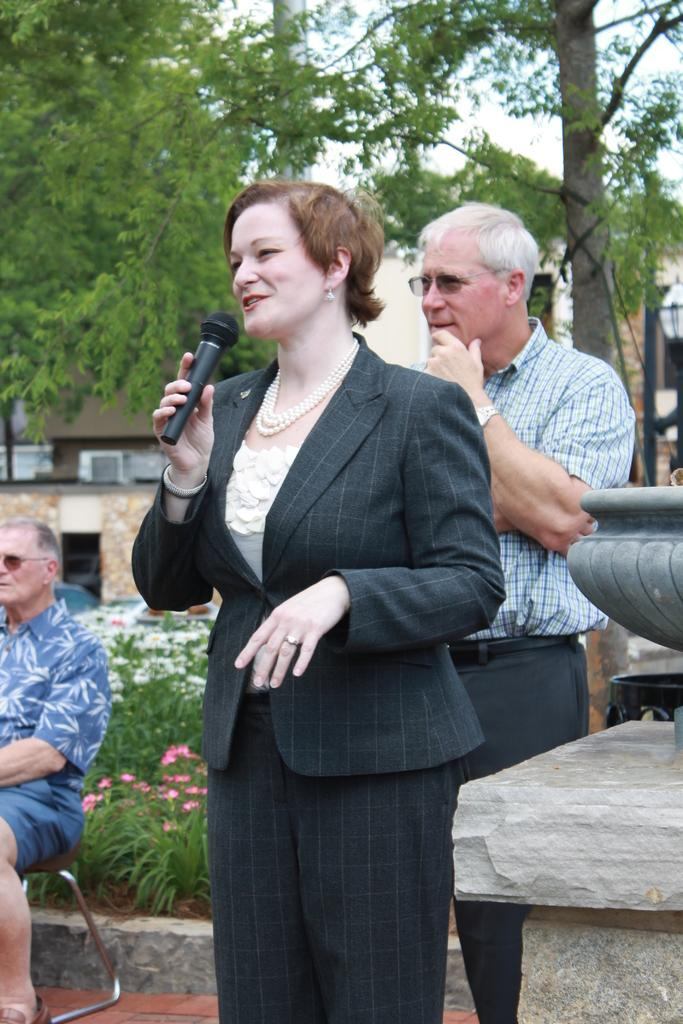Who is the main subject in the image? There is a woman in the image. What is the woman doing in the image? The woman is speaking and smiling. What object is the woman holding in her right hand? The woman is holding a microphone in her right hand. Can you describe the person behind the woman? The person behind the woman is standing and smiling. What is the woman adding to the cake in the image? There is no cake present in the image, so it is not possible to determine what the woman might be adding to it. 